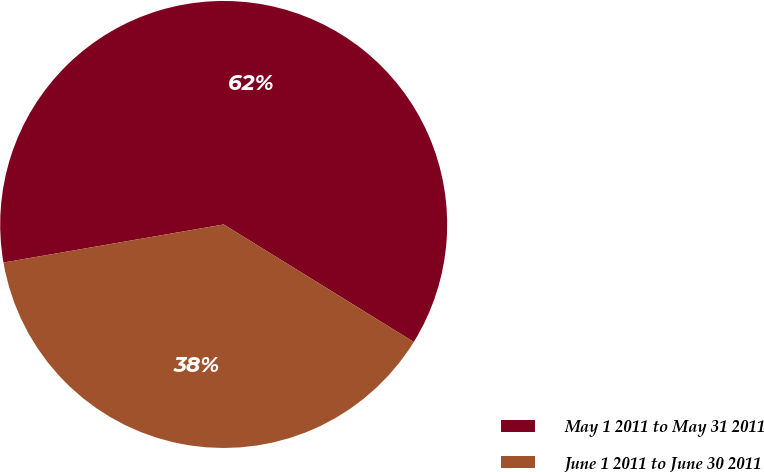Convert chart. <chart><loc_0><loc_0><loc_500><loc_500><pie_chart><fcel>May 1 2011 to May 31 2011<fcel>June 1 2011 to June 30 2011<nl><fcel>61.54%<fcel>38.46%<nl></chart> 